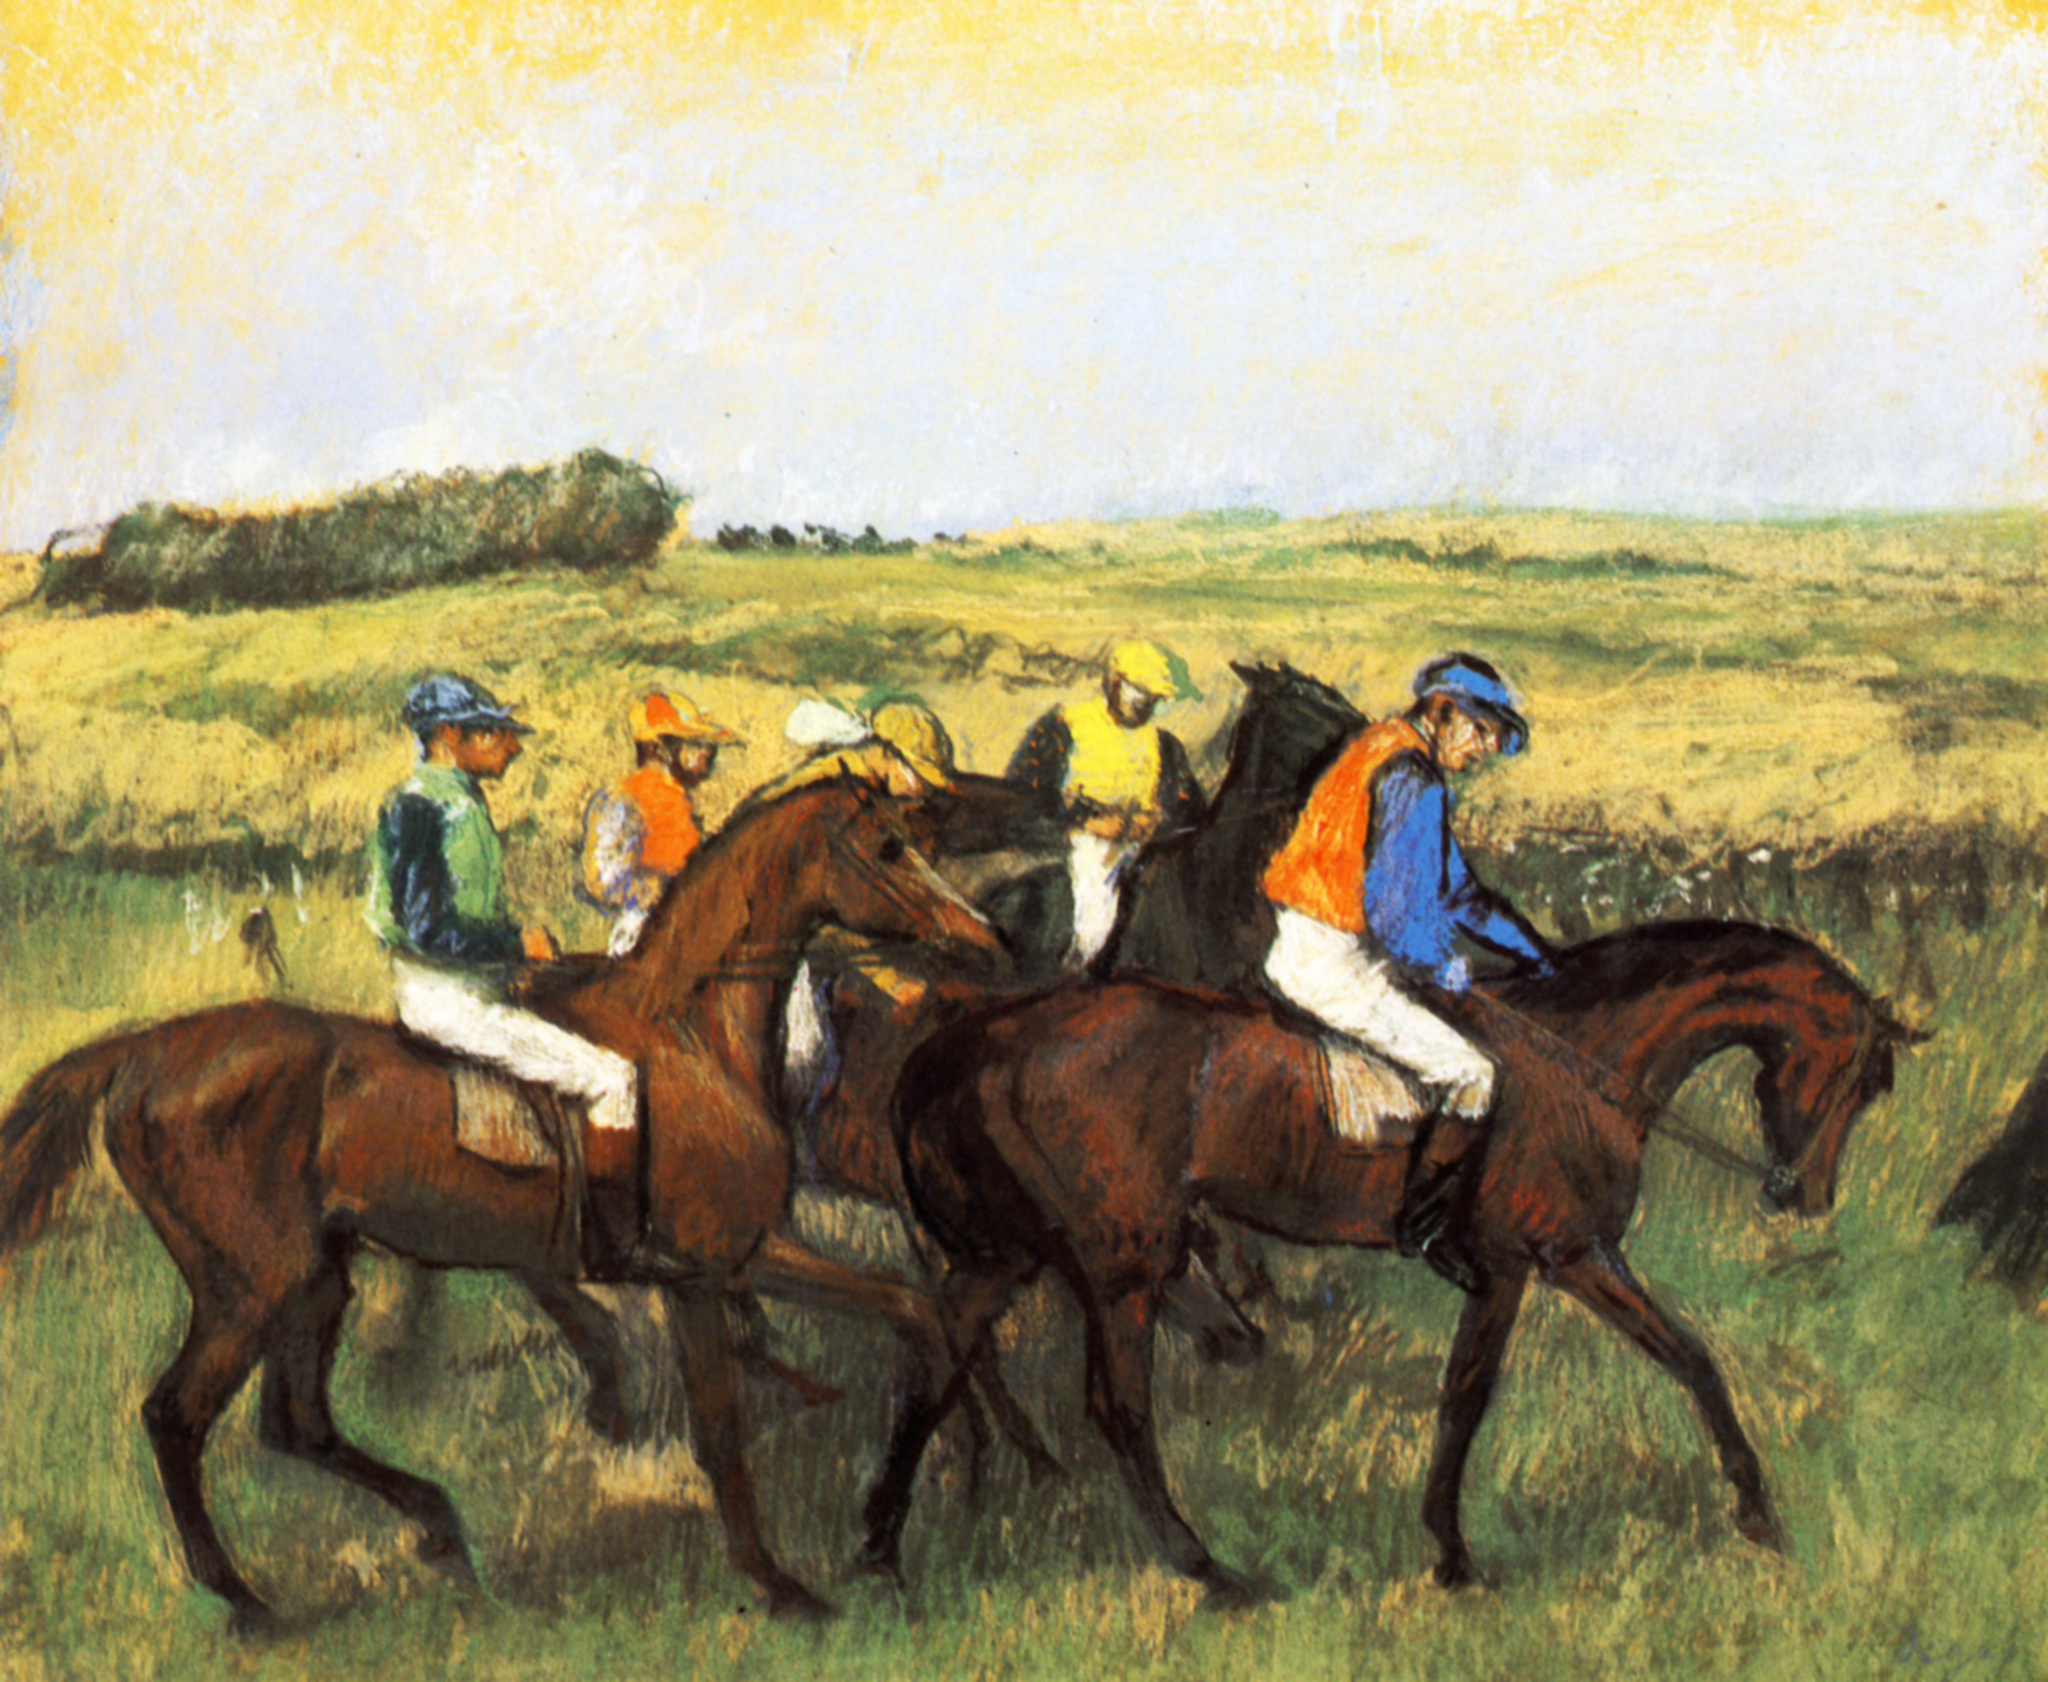Can you discuss the technique used in this painting and how it contributes to the overall feel? The painting uses a vibrant expressionist technique characterized by vigorous brushstrokes and bold color choices. These elements enhance the feeling of motion and urgency in the horse race. The brushstrokes create a texture that seems to vibrate, mirroring the racers' dynamic movement, while the deliberate use of bright colors for the jockeys' attire contrasts sharply against the more subdued background. This contrast not only focuses the viewer's attention on the race but also heightens the emotional impact of the scene. 